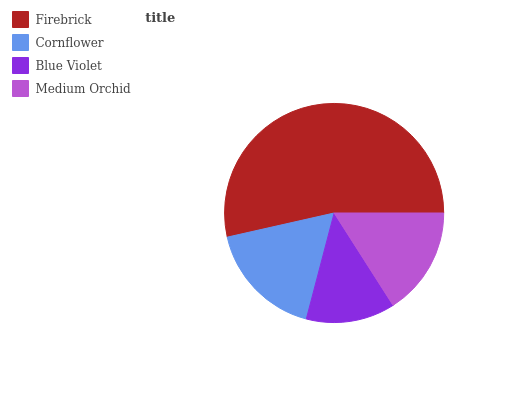Is Blue Violet the minimum?
Answer yes or no. Yes. Is Firebrick the maximum?
Answer yes or no. Yes. Is Cornflower the minimum?
Answer yes or no. No. Is Cornflower the maximum?
Answer yes or no. No. Is Firebrick greater than Cornflower?
Answer yes or no. Yes. Is Cornflower less than Firebrick?
Answer yes or no. Yes. Is Cornflower greater than Firebrick?
Answer yes or no. No. Is Firebrick less than Cornflower?
Answer yes or no. No. Is Cornflower the high median?
Answer yes or no. Yes. Is Medium Orchid the low median?
Answer yes or no. Yes. Is Blue Violet the high median?
Answer yes or no. No. Is Firebrick the low median?
Answer yes or no. No. 